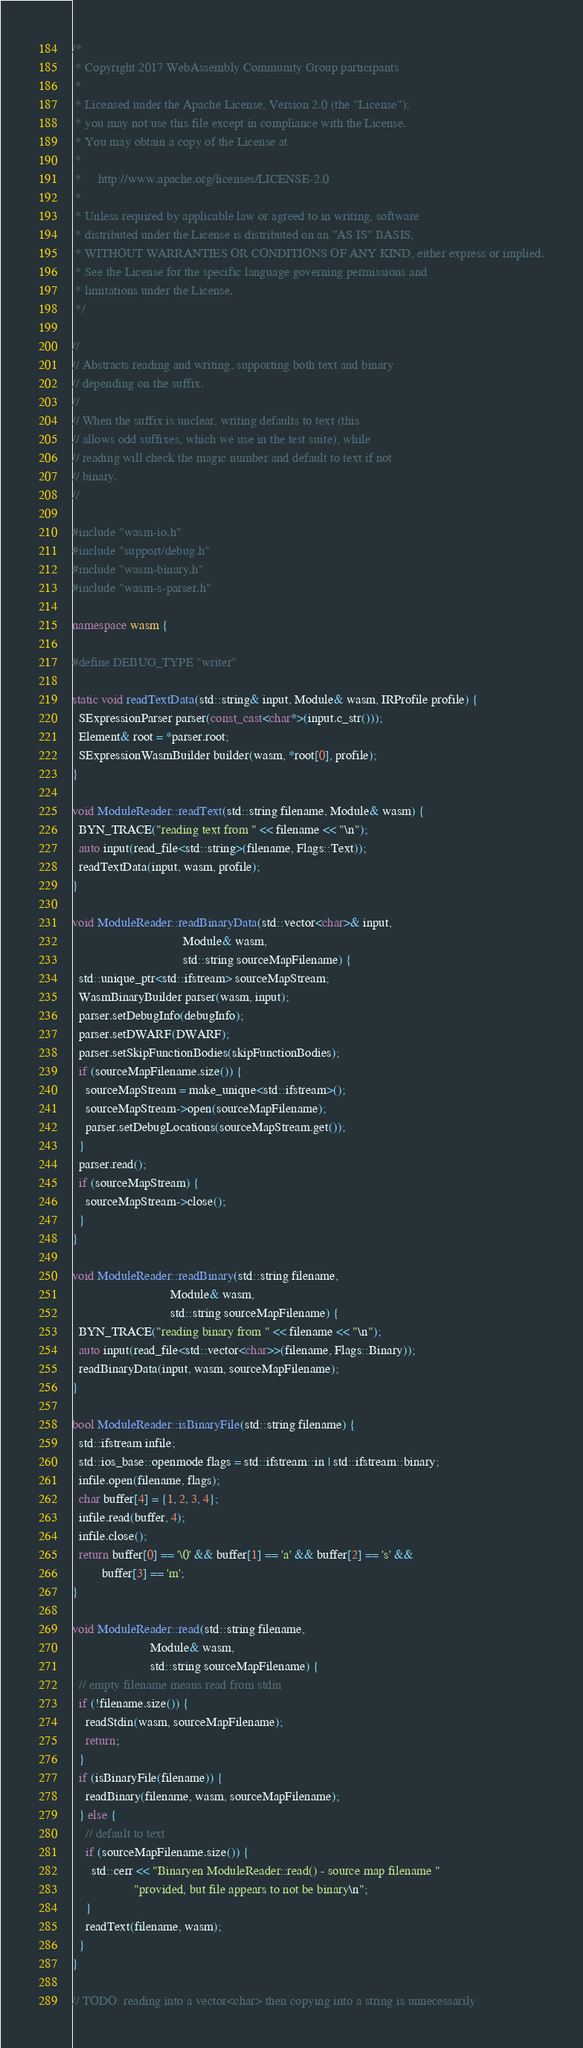<code> <loc_0><loc_0><loc_500><loc_500><_C++_>/*
 * Copyright 2017 WebAssembly Community Group participants
 *
 * Licensed under the Apache License, Version 2.0 (the "License");
 * you may not use this file except in compliance with the License.
 * You may obtain a copy of the License at
 *
 *     http://www.apache.org/licenses/LICENSE-2.0
 *
 * Unless required by applicable law or agreed to in writing, software
 * distributed under the License is distributed on an "AS IS" BASIS,
 * WITHOUT WARRANTIES OR CONDITIONS OF ANY KIND, either express or implied.
 * See the License for the specific language governing permissions and
 * limitations under the License.
 */

//
// Abstracts reading and writing, supporting both text and binary
// depending on the suffix.
//
// When the suffix is unclear, writing defaults to text (this
// allows odd suffixes, which we use in the test suite), while
// reading will check the magic number and default to text if not
// binary.
//

#include "wasm-io.h"
#include "support/debug.h"
#include "wasm-binary.h"
#include "wasm-s-parser.h"

namespace wasm {

#define DEBUG_TYPE "writer"

static void readTextData(std::string& input, Module& wasm, IRProfile profile) {
  SExpressionParser parser(const_cast<char*>(input.c_str()));
  Element& root = *parser.root;
  SExpressionWasmBuilder builder(wasm, *root[0], profile);
}

void ModuleReader::readText(std::string filename, Module& wasm) {
  BYN_TRACE("reading text from " << filename << "\n");
  auto input(read_file<std::string>(filename, Flags::Text));
  readTextData(input, wasm, profile);
}

void ModuleReader::readBinaryData(std::vector<char>& input,
                                  Module& wasm,
                                  std::string sourceMapFilename) {
  std::unique_ptr<std::ifstream> sourceMapStream;
  WasmBinaryBuilder parser(wasm, input);
  parser.setDebugInfo(debugInfo);
  parser.setDWARF(DWARF);
  parser.setSkipFunctionBodies(skipFunctionBodies);
  if (sourceMapFilename.size()) {
    sourceMapStream = make_unique<std::ifstream>();
    sourceMapStream->open(sourceMapFilename);
    parser.setDebugLocations(sourceMapStream.get());
  }
  parser.read();
  if (sourceMapStream) {
    sourceMapStream->close();
  }
}

void ModuleReader::readBinary(std::string filename,
                              Module& wasm,
                              std::string sourceMapFilename) {
  BYN_TRACE("reading binary from " << filename << "\n");
  auto input(read_file<std::vector<char>>(filename, Flags::Binary));
  readBinaryData(input, wasm, sourceMapFilename);
}

bool ModuleReader::isBinaryFile(std::string filename) {
  std::ifstream infile;
  std::ios_base::openmode flags = std::ifstream::in | std::ifstream::binary;
  infile.open(filename, flags);
  char buffer[4] = {1, 2, 3, 4};
  infile.read(buffer, 4);
  infile.close();
  return buffer[0] == '\0' && buffer[1] == 'a' && buffer[2] == 's' &&
         buffer[3] == 'm';
}

void ModuleReader::read(std::string filename,
                        Module& wasm,
                        std::string sourceMapFilename) {
  // empty filename means read from stdin
  if (!filename.size()) {
    readStdin(wasm, sourceMapFilename);
    return;
  }
  if (isBinaryFile(filename)) {
    readBinary(filename, wasm, sourceMapFilename);
  } else {
    // default to text
    if (sourceMapFilename.size()) {
      std::cerr << "Binaryen ModuleReader::read() - source map filename "
                   "provided, but file appears to not be binary\n";
    }
    readText(filename, wasm);
  }
}

// TODO: reading into a vector<char> then copying into a string is unnecessarily</code> 